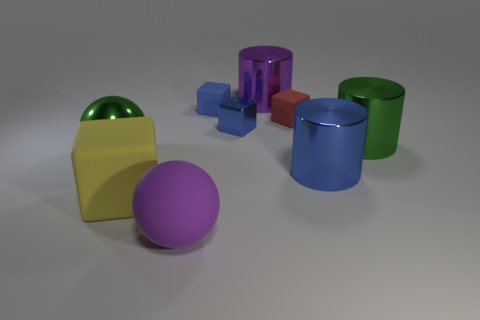There is a ball that is in front of the big metallic ball; is it the same color as the metallic ball?
Your answer should be compact. No. The shiny thing that is in front of the large green shiny object that is left of the big green metallic object that is behind the large green metallic ball is what shape?
Provide a short and direct response. Cylinder. There is a large purple object that is in front of the large green cylinder; what number of large blue cylinders are in front of it?
Ensure brevity in your answer.  0. Do the large blue object and the small red thing have the same material?
Provide a short and direct response. No. What number of purple rubber balls are on the left side of the big green object that is in front of the metallic thing on the right side of the large blue metal cylinder?
Provide a succinct answer. 0. What is the color of the metallic object that is left of the purple matte object?
Offer a terse response. Green. What shape is the big purple object behind the green thing behind the green metallic ball?
Your response must be concise. Cylinder. Does the large shiny ball have the same color as the shiny block?
Your answer should be compact. No. How many cylinders are purple things or small red matte objects?
Offer a very short reply. 1. There is a object that is both behind the tiny red matte object and right of the tiny blue rubber cube; what material is it made of?
Keep it short and to the point. Metal. 